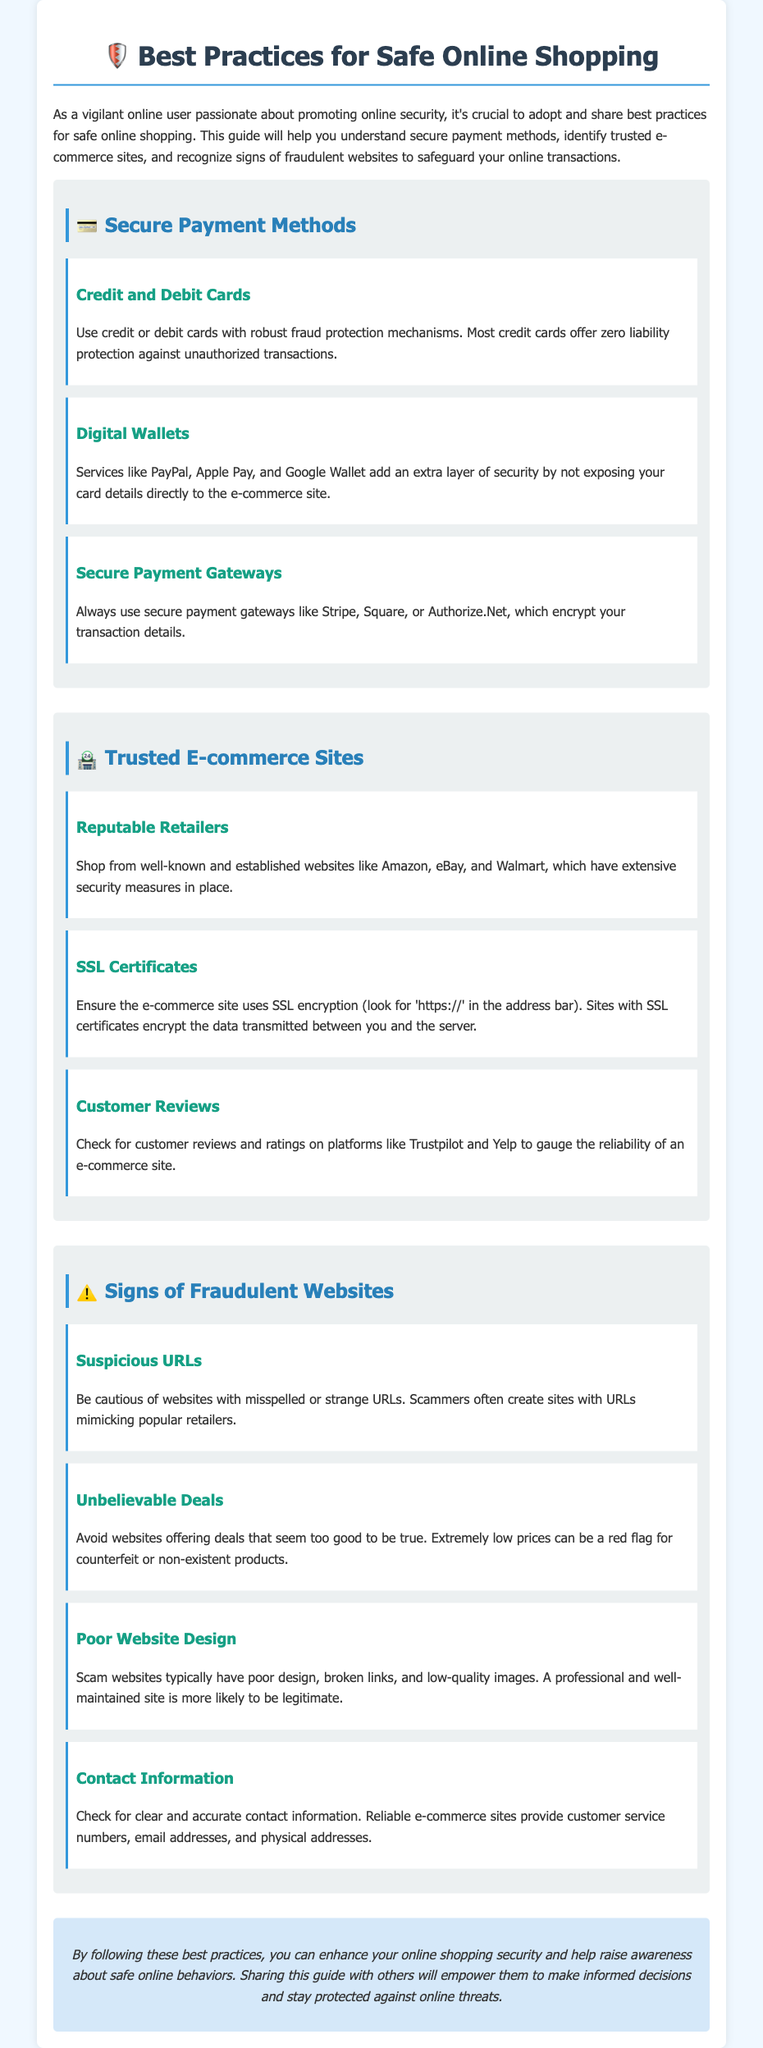What are the three secure payment methods mentioned? The document lists three secure payment methods: Credit and Debit Cards, Digital Wallets, and Secure Payment Gateways.
Answer: Credit and Debit Cards, Digital Wallets, Secure Payment Gateways What should you ensure is present in a trusted e-commerce site? To identify a trusted e-commerce site, one should look for SSL certificates, indicated by 'https://' in the address bar.
Answer: SSL certificates What is a sign of a fraudulent website according to the guide? The guide states that suspicious URLs, unbelievable deals, and poor website design are signs of fraudulent websites.
Answer: Suspicious URLs, unbelievable deals, poor website design Which payment service adds security by not exposing card details? The document specifies that services like PayPal, Apple Pay, and Google Wallet add extra security by not revealing your card details.
Answer: Digital Wallets What does the guide recommend checking for a reliable e-commerce site? The guide recommends checking customer reviews and ratings to gauge the reliability of an e-commerce site.
Answer: Customer reviews How does the document categorize payment methods? The document categorizes payment methods into Secure Payment Methods, Trusted E-commerce Sites, and Signs of Fraudulent Websites.
Answer: Secure Payment Methods, Trusted E-commerce Sites, Signs of Fraudulent Websites What type of information does a reliable e-commerce site provide? It provides clear and accurate contact information, including customer service numbers, email addresses, and physical addresses.
Answer: Contact Information What is the main purpose of this user guide? The main purpose of the user guide is to promote best practices for safe online shopping and enhance online security awareness.
Answer: Promote best practices for safe online shopping 